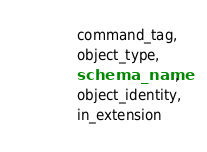<code> <loc_0><loc_0><loc_500><loc_500><_SQL_>            command_tag,
            object_type,
            schema_name,
            object_identity,
            in_extension</code> 